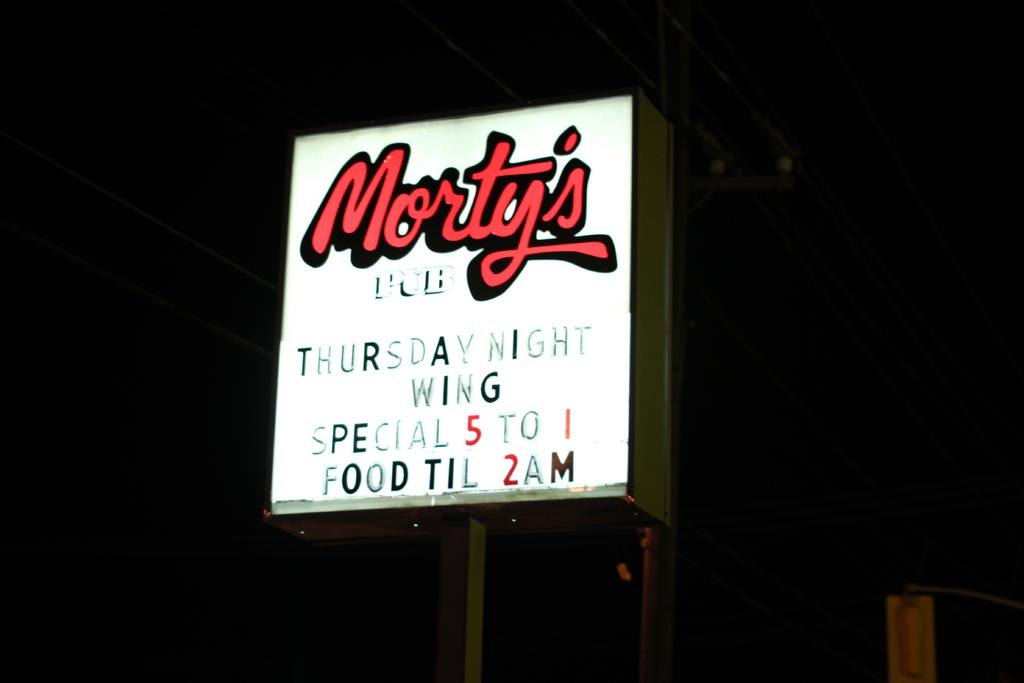<image>
Give a short and clear explanation of the subsequent image. Morty's Pub restaurant having Thursday Night Wing Specials 5 to 1 and Food till 2 AM. 